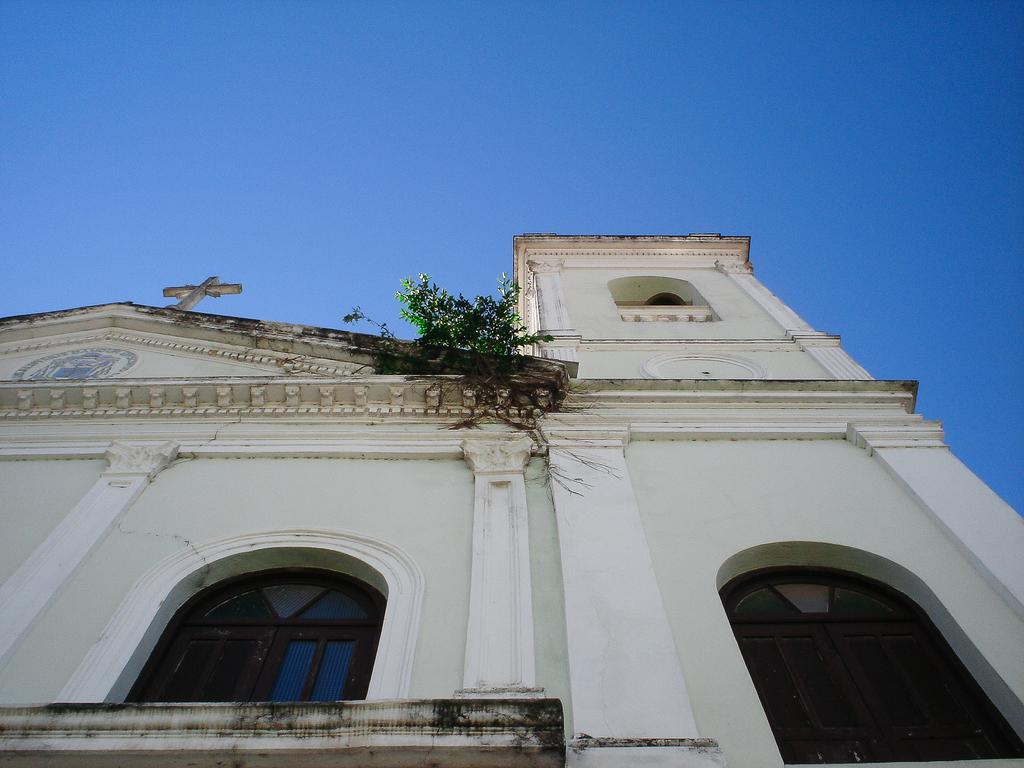What is the main subject in the center of the image? There is a building and a tree in the center of the image. Can you describe the building in the image? Unfortunately, the facts provided do not give any details about the building. What can be seen in the background of the image? The sky is visible in the background of the image. How many ducks are sitting on the tree in the image? There are no ducks present in the image; it features a building and a tree. What color is the uncle's hat in the image? There is no uncle or hat present in the image. 